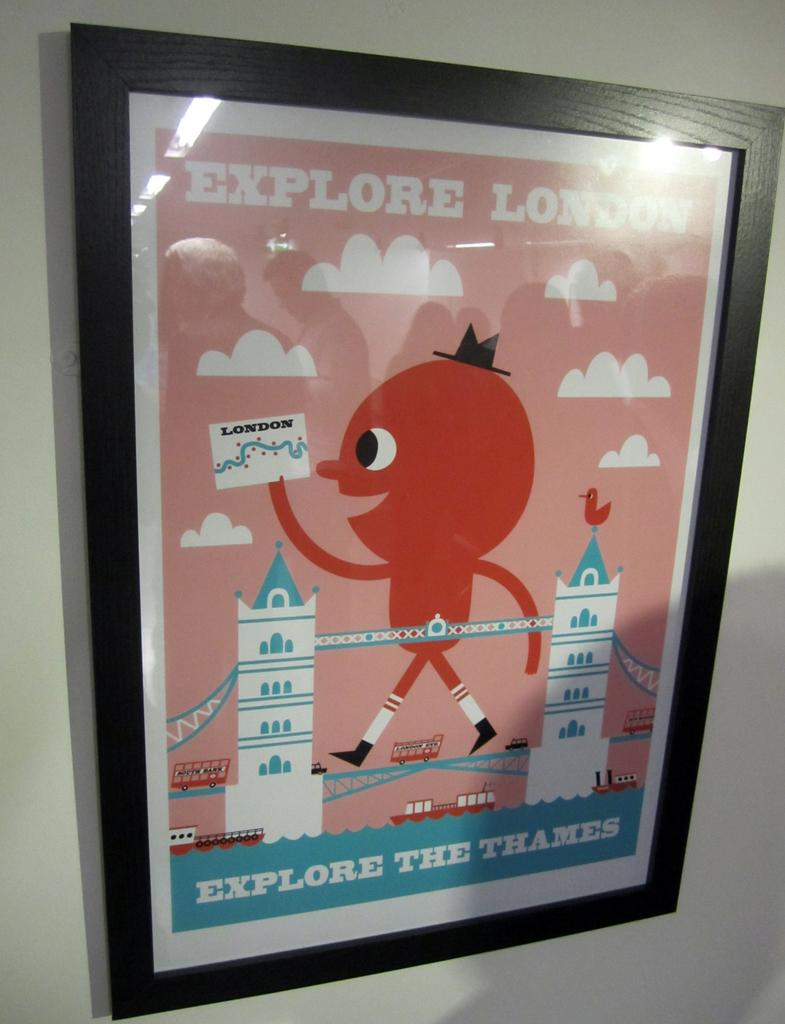<image>
Summarize the visual content of the image. A red and blue sign with Explore London on it 